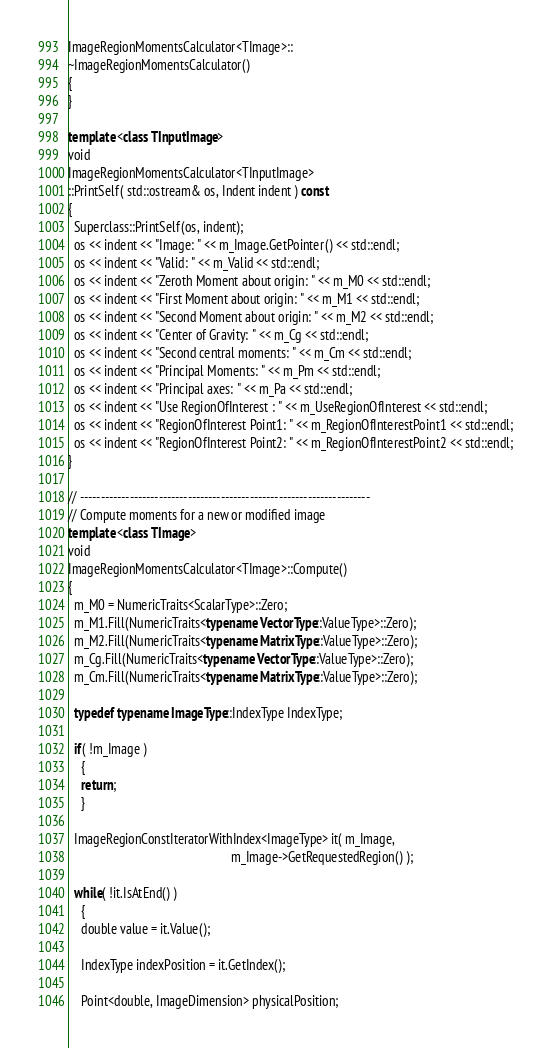<code> <loc_0><loc_0><loc_500><loc_500><_C++_>ImageRegionMomentsCalculator<TImage>::
~ImageRegionMomentsCalculator()
{
}

template <class TInputImage>
void
ImageRegionMomentsCalculator<TInputImage>
::PrintSelf( std::ostream& os, Indent indent ) const
{
  Superclass::PrintSelf(os, indent);
  os << indent << "Image: " << m_Image.GetPointer() << std::endl;
  os << indent << "Valid: " << m_Valid << std::endl;
  os << indent << "Zeroth Moment about origin: " << m_M0 << std::endl;
  os << indent << "First Moment about origin: " << m_M1 << std::endl;
  os << indent << "Second Moment about origin: " << m_M2 << std::endl;
  os << indent << "Center of Gravity: " << m_Cg << std::endl;
  os << indent << "Second central moments: " << m_Cm << std::endl;
  os << indent << "Principal Moments: " << m_Pm << std::endl;
  os << indent << "Principal axes: " << m_Pa << std::endl;
  os << indent << "Use RegionOfInterest : " << m_UseRegionOfInterest << std::endl;
  os << indent << "RegionOfInterest Point1: " << m_RegionOfInterestPoint1 << std::endl;
  os << indent << "RegionOfInterest Point2: " << m_RegionOfInterestPoint2 << std::endl;
}

// ----------------------------------------------------------------------
// Compute moments for a new or modified image
template <class TImage>
void
ImageRegionMomentsCalculator<TImage>::Compute()
{
  m_M0 = NumericTraits<ScalarType>::Zero;
  m_M1.Fill(NumericTraits<typename VectorType::ValueType>::Zero);
  m_M2.Fill(NumericTraits<typename MatrixType::ValueType>::Zero);
  m_Cg.Fill(NumericTraits<typename VectorType::ValueType>::Zero);
  m_Cm.Fill(NumericTraits<typename MatrixType::ValueType>::Zero);

  typedef typename ImageType::IndexType IndexType;

  if( !m_Image )
    {
    return;
    }

  ImageRegionConstIteratorWithIndex<ImageType> it( m_Image,
                                                   m_Image->GetRequestedRegion() );

  while( !it.IsAtEnd() )
    {
    double value = it.Value();

    IndexType indexPosition = it.GetIndex();

    Point<double, ImageDimension> physicalPosition;</code> 